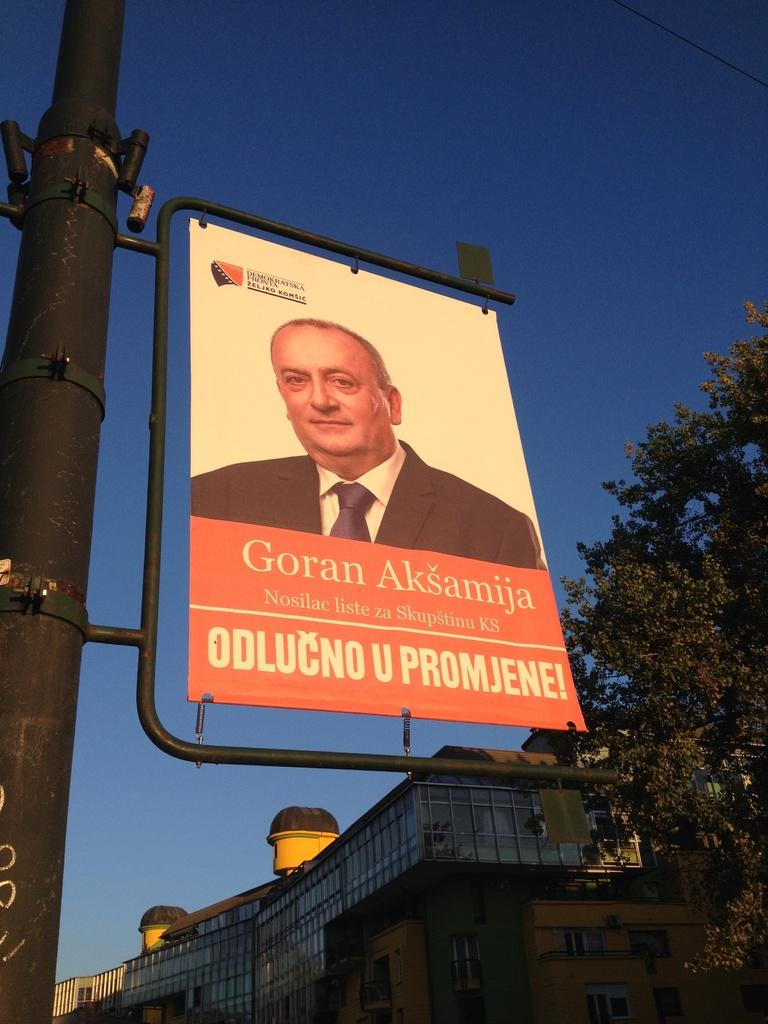<image>
Render a clear and concise summary of the photo. A older man named Goran Aksamija is pictured on a banner hanging from a light pole. 